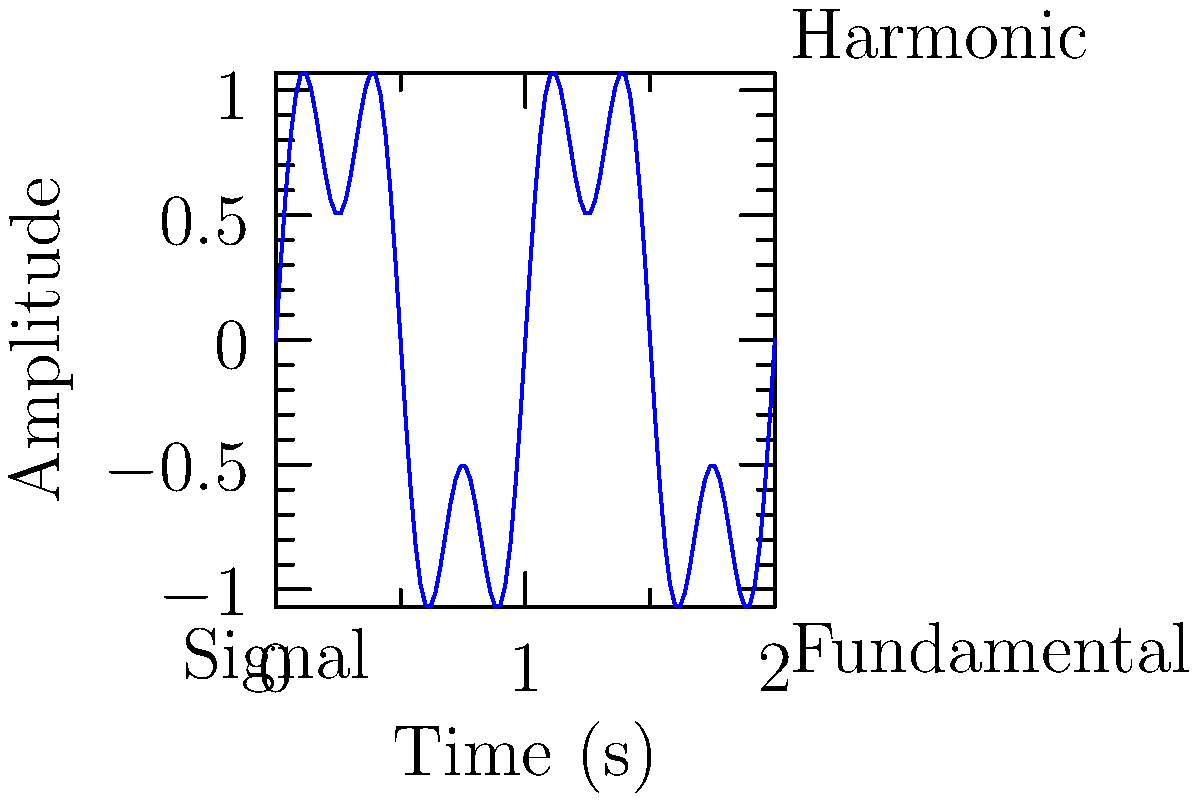In the context of analyzing disinformation campaigns, consider a digital signal carrying encoded misleading information. The signal's waveform is shown above, composed of a fundamental frequency and its third harmonic. If the fundamental frequency is 100 Hz, what is the highest frequency component present in this signal's spectrum? To determine the highest frequency component in the signal's spectrum, we need to follow these steps:

1. Identify the components of the signal:
   - The signal consists of a fundamental frequency and its third harmonic.
   - The fundamental frequency is given as 100 Hz.

2. Calculate the frequency of the third harmonic:
   - The third harmonic is 3 times the fundamental frequency.
   - Third harmonic frequency = $3 \times 100$ Hz = 300 Hz

3. Compare the frequencies:
   - Fundamental frequency: 100 Hz
   - Third harmonic frequency: 300 Hz

4. Identify the highest frequency:
   - The third harmonic (300 Hz) is higher than the fundamental (100 Hz).

Therefore, the highest frequency component present in this signal's spectrum is 300 Hz, which corresponds to the third harmonic of the fundamental frequency.
Answer: 300 Hz 